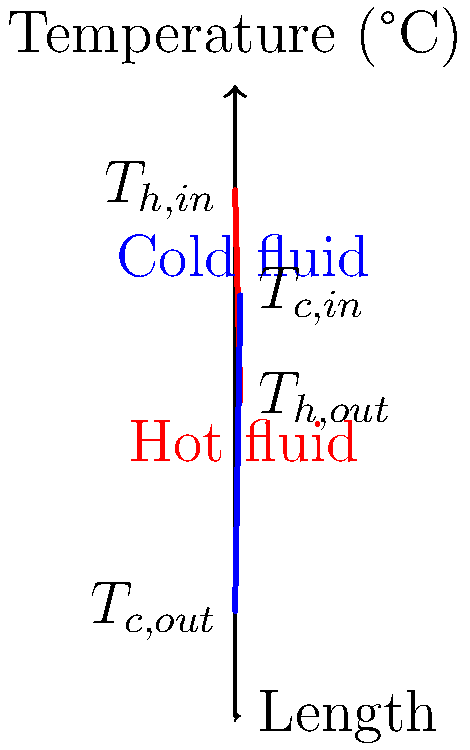In the counter-flow heat exchanger shown above, the hot fluid enters at 100°C and exits at 60°C, while the cold fluid enters at 20°C and exits at 80°C. Calculate the log mean temperature difference (LMTD) for this heat exchanger. To calculate the log mean temperature difference (LMTD) for a counter-flow heat exchanger, we'll follow these steps:

1. Identify the temperature differences at both ends of the heat exchanger:
   $\Delta T_1 = T_{h,in} - T_{c,out} = 100°C - 80°C = 20°C$
   $\Delta T_2 = T_{h,out} - T_{c,in} = 60°C - 20°C = 40°C$

2. Apply the LMTD formula:
   $LMTD = \frac{\Delta T_2 - \Delta T_1}{\ln(\frac{\Delta T_2}{\Delta T_1})}$

3. Substitute the values:
   $LMTD = \frac{40°C - 20°C}{\ln(\frac{40°C}{20°C})}$

4. Simplify:
   $LMTD = \frac{20°C}{\ln(2)}$

5. Calculate the final result:
   $LMTD \approx 28.85°C$

The log mean temperature difference for this counter-flow heat exchanger is approximately 28.85°C.
Answer: 28.85°C 